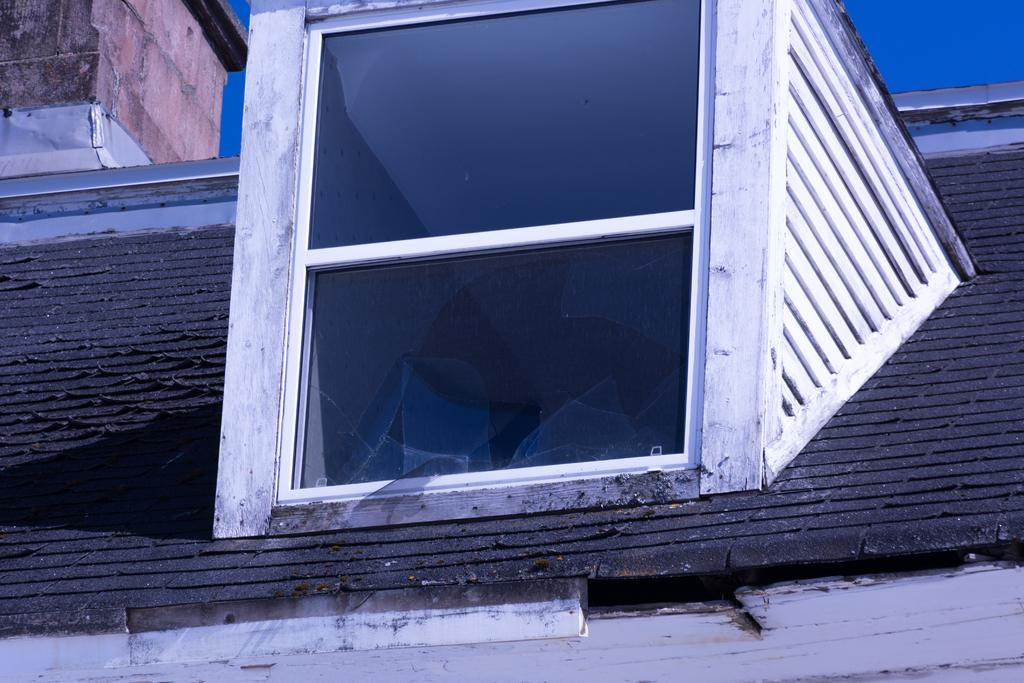What type of structure is present in the image? There is a shed in the image. What feature can be seen on the shed? There is a window in the shed. What can be seen in the background of the image? The sky is visible in the background of the image. How many bars of soap are on the windowsill in the image? There is no soap present in the image. Are there any babies visible in the image? There are no babies present in the image. 